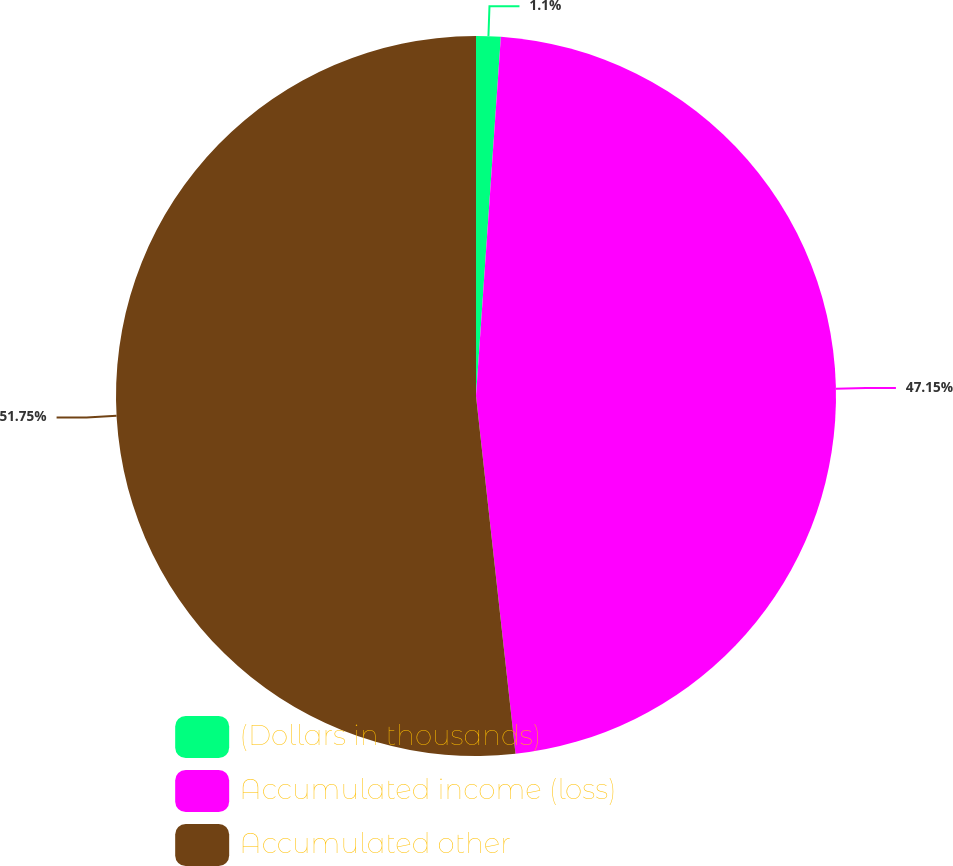Convert chart. <chart><loc_0><loc_0><loc_500><loc_500><pie_chart><fcel>(Dollars in thousands)<fcel>Accumulated income (loss)<fcel>Accumulated other<nl><fcel>1.1%<fcel>47.15%<fcel>51.75%<nl></chart> 